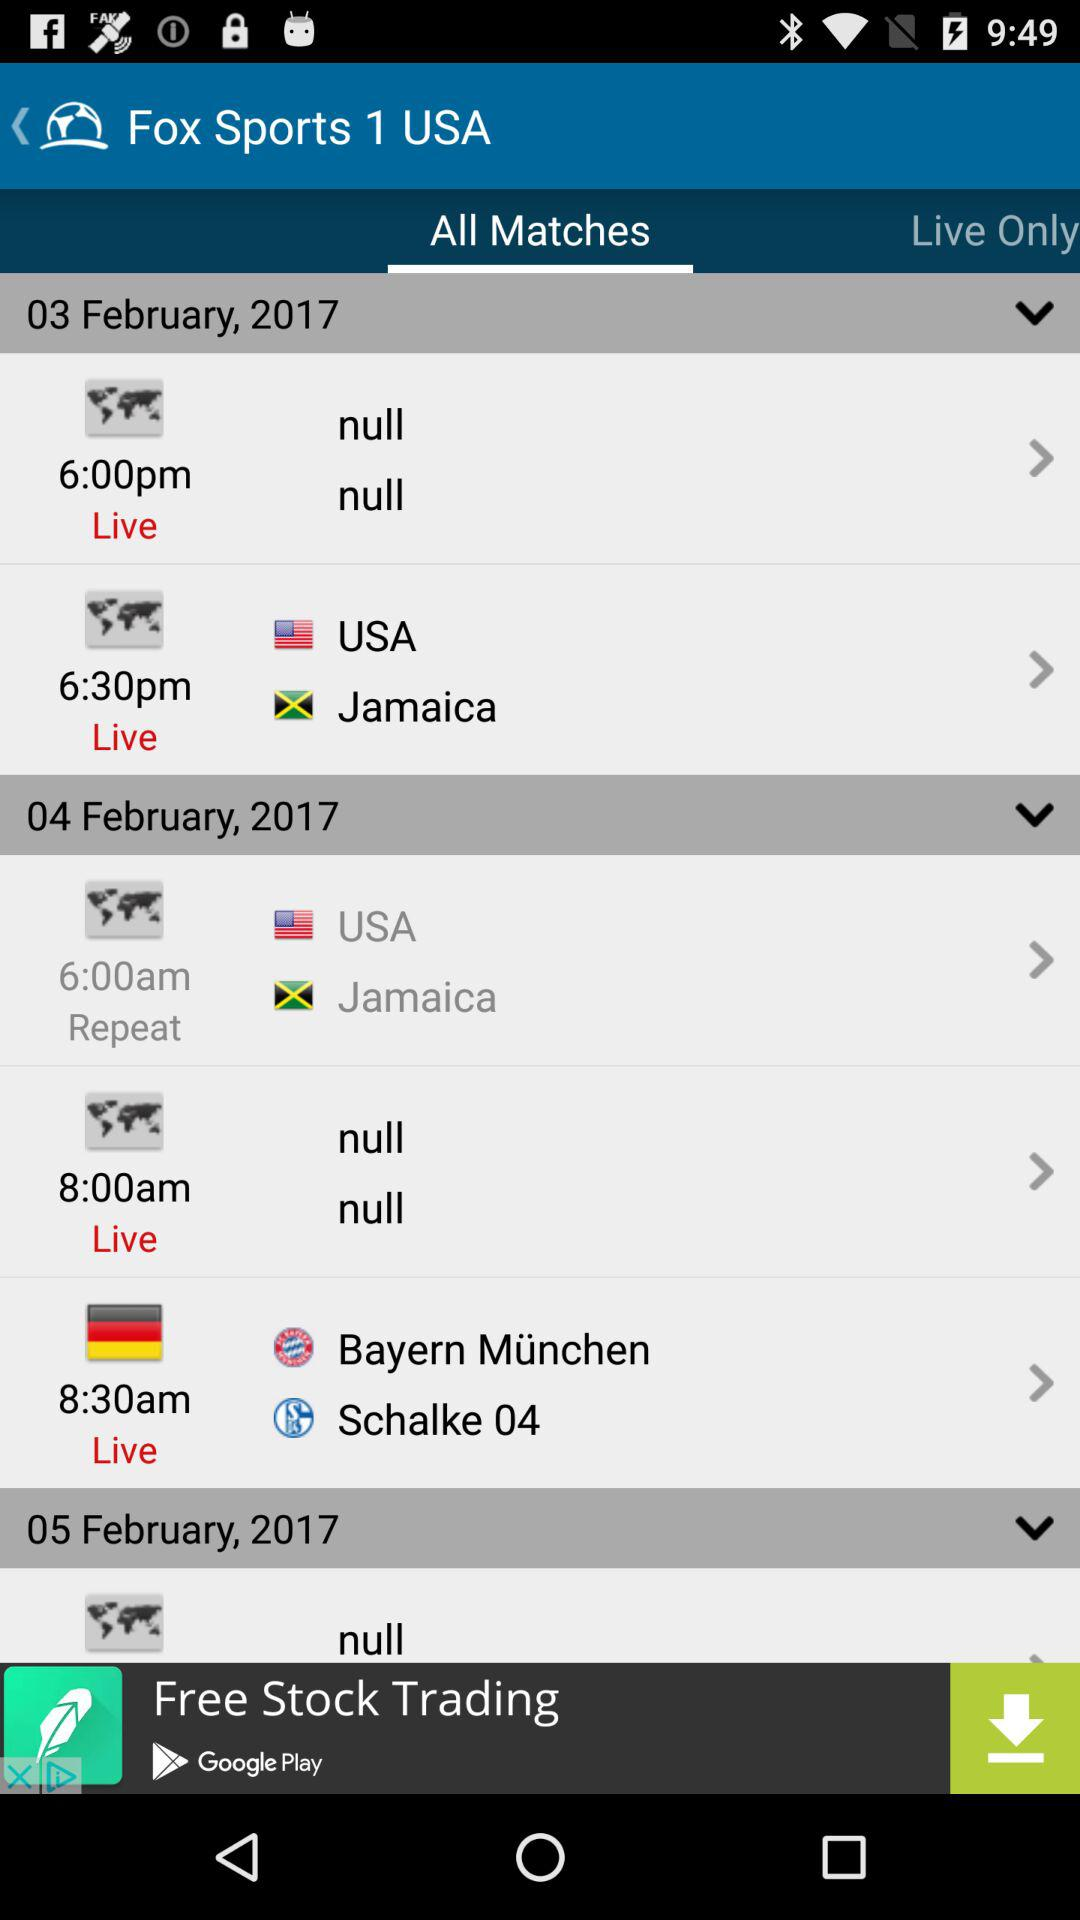How many matches are scheduled for the 04th of February?
Answer the question using a single word or phrase. 2 